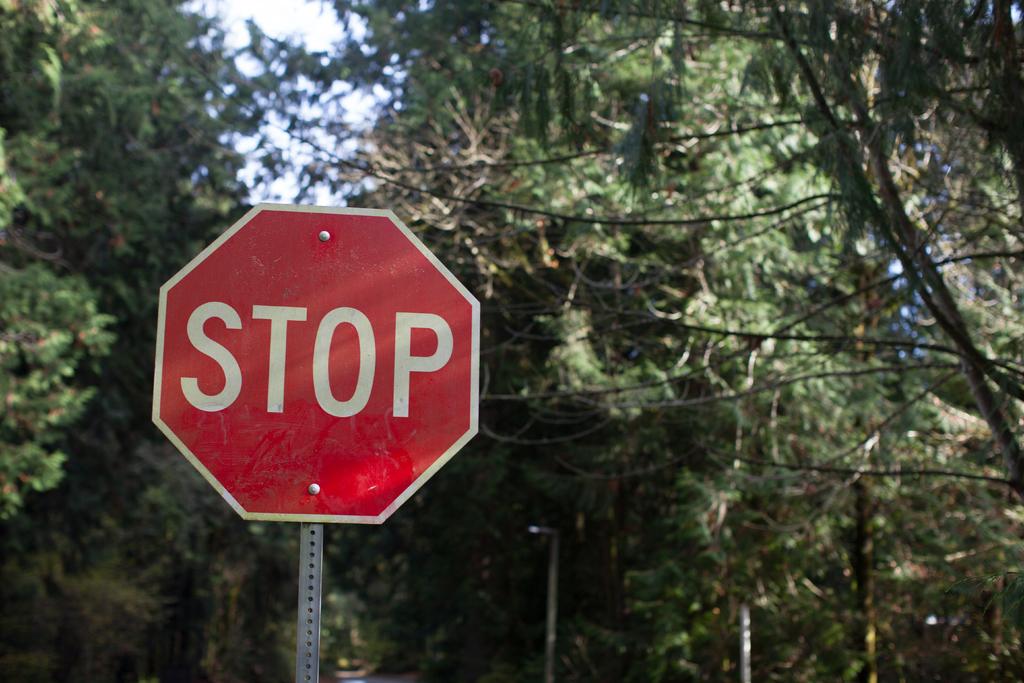What does the sign say to do?
Provide a short and direct response. Stop. 